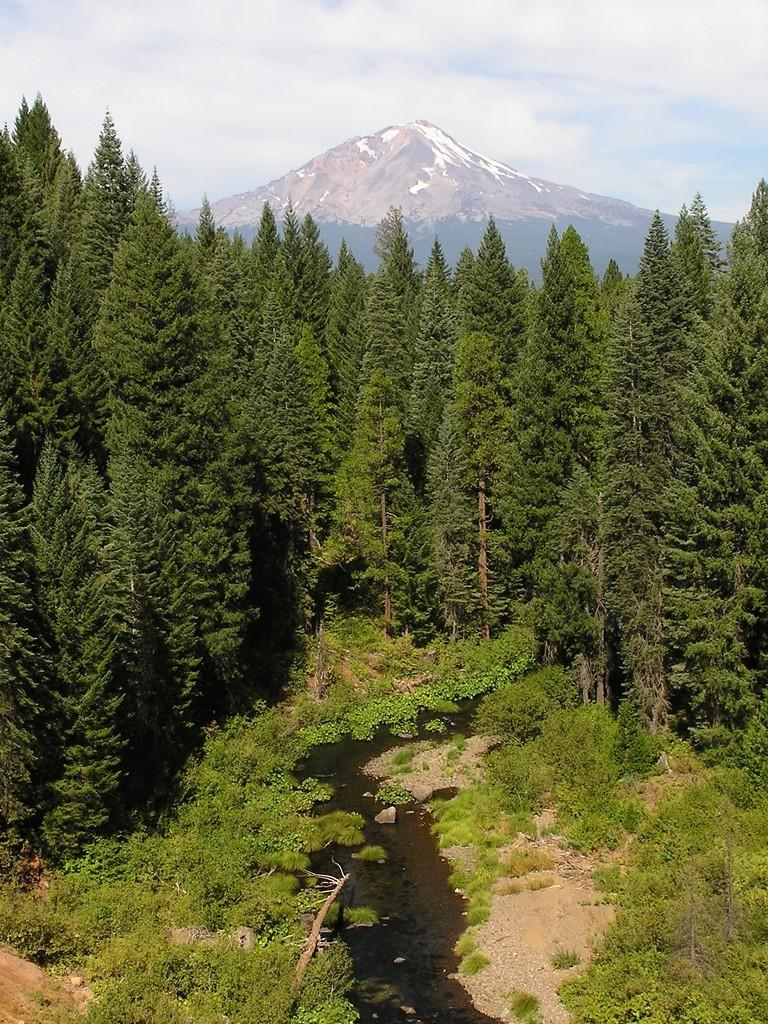What type of natural elements can be seen in the image? There are trees in the image. What can be seen in the distance in the image? There is a hill visible in the background of the image. What else is visible in the background of the image? Clouds are present in the background of the image. What type of clock is hanging from the tree in the image? There is no clock present in the image; it only features trees, a hill, and clouds. 